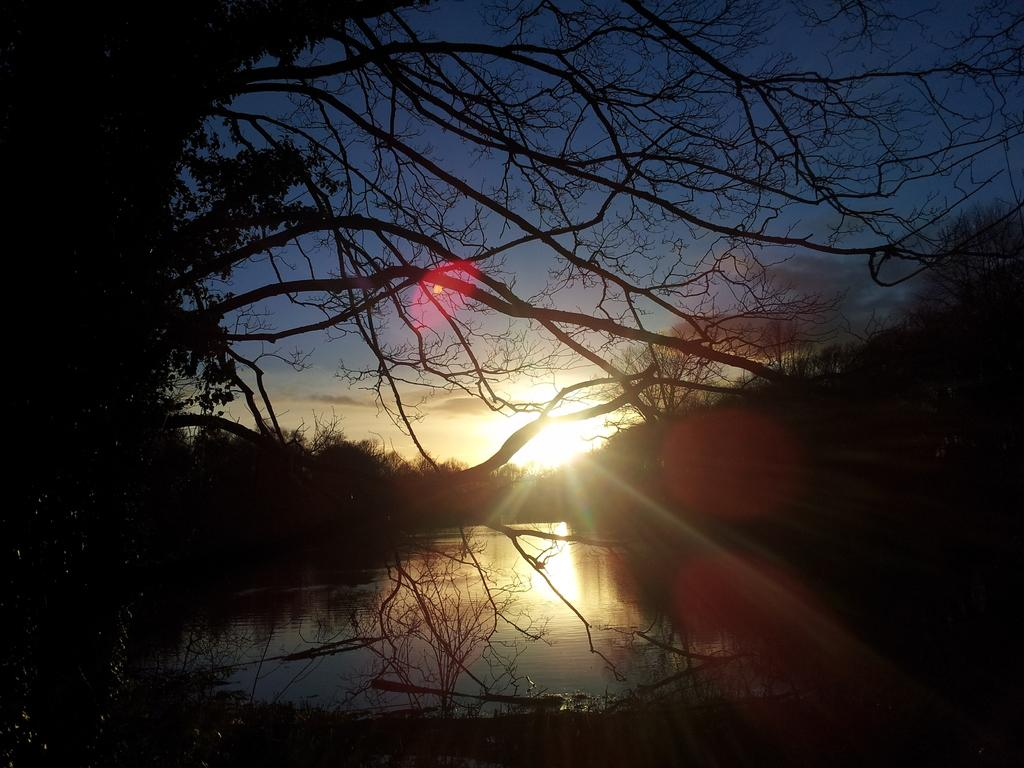What is the overall lighting condition in the image? The image is dark. What type of natural element can be seen in the image? There is a tree in the image. What can be seen besides the tree in the image? There is water visible in the image. What is visible at the top of the image? The sky is visible at the top of the image. What type of string can be seen connecting the planets in the image? There is no string connecting planets in the image, as it does not depict a space scene. Can you hear a whistle in the image? There is no whistle present in the image, as it is a still image and cannot produce sound. 